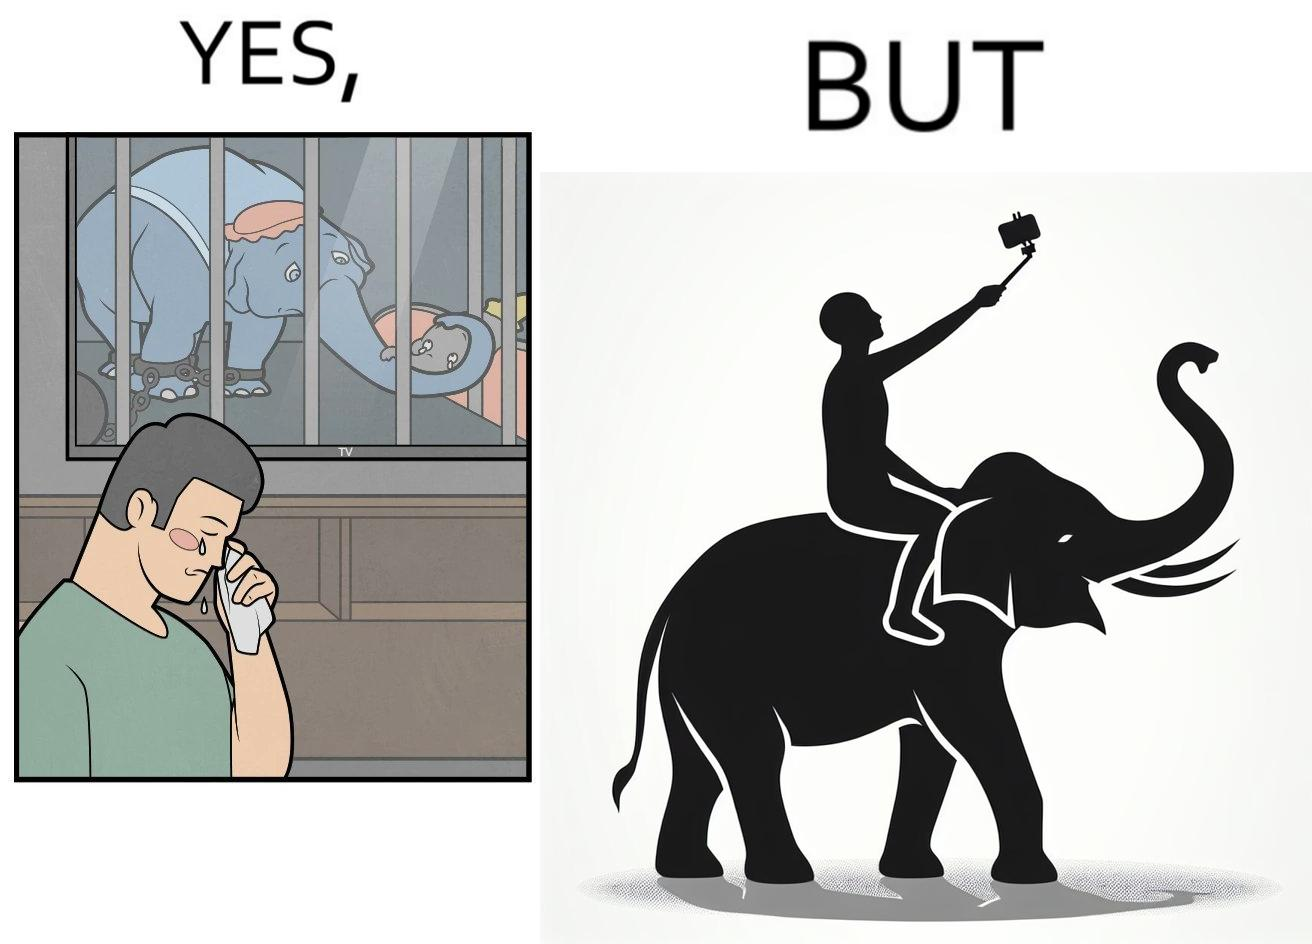What is shown in the left half versus the right half of this image? In the left part of the image: a man crying on seeing an elephant being chained in a cage in a TV program In the right part of the image: a person riding an elephant while taking selfies 